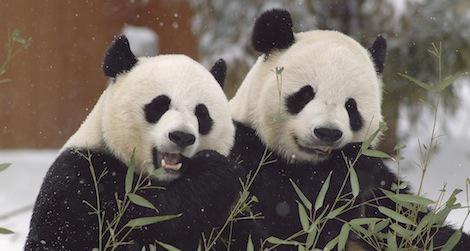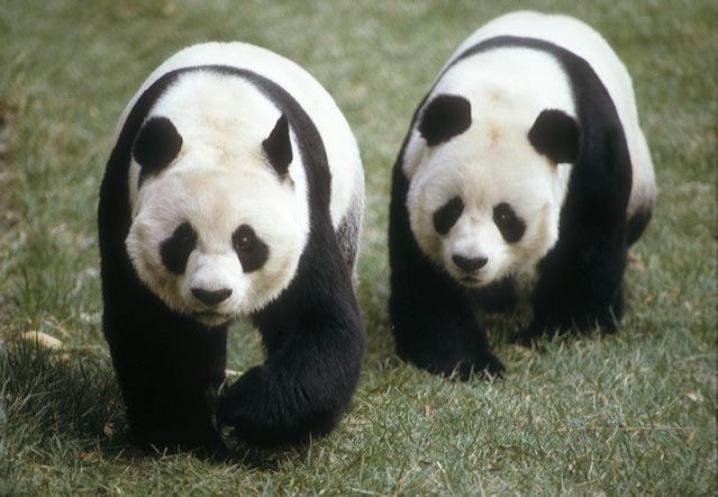The first image is the image on the left, the second image is the image on the right. Assess this claim about the two images: "The two pandas in the image on the left are eating bamboo shoots.". Correct or not? Answer yes or no. Yes. The first image is the image on the left, the second image is the image on the right. Examine the images to the left and right. Is the description "Two pandas are face-to-face, one with its front paws touching the other, in the right image." accurate? Answer yes or no. No. 